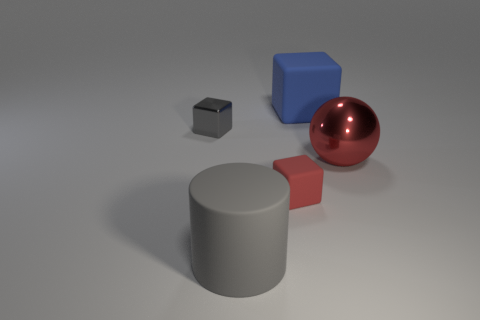Add 3 red spheres. How many objects exist? 8 Subtract all gray cubes. How many cubes are left? 2 Subtract all tiny shiny cubes. How many cubes are left? 2 Subtract 0 purple balls. How many objects are left? 5 Subtract all balls. How many objects are left? 4 Subtract 1 cylinders. How many cylinders are left? 0 Subtract all yellow balls. Subtract all gray cubes. How many balls are left? 1 Subtract all cyan cubes. How many gray spheres are left? 0 Subtract all cubes. Subtract all gray rubber cylinders. How many objects are left? 1 Add 4 small gray cubes. How many small gray cubes are left? 5 